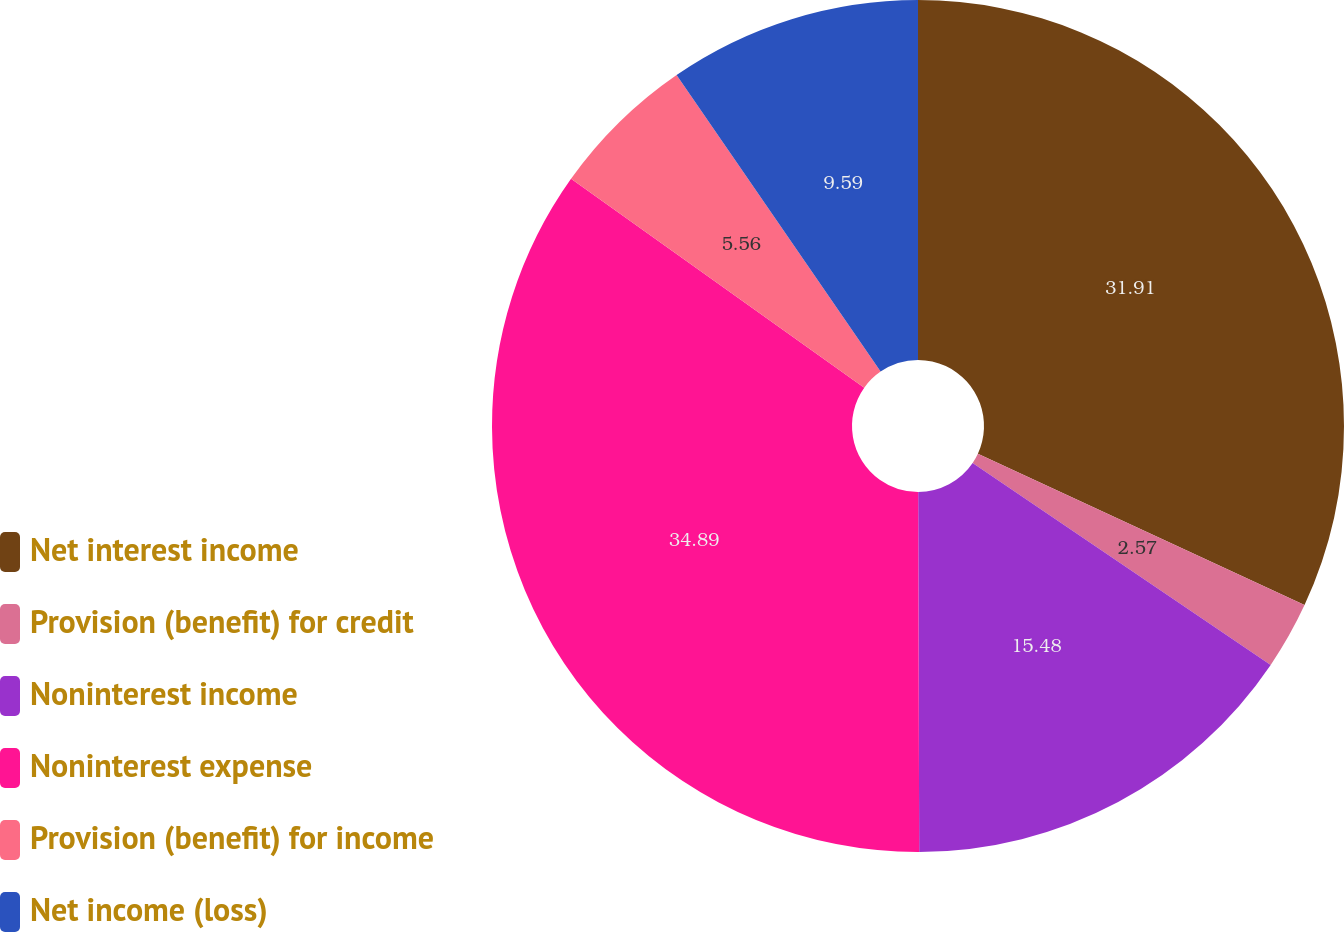Convert chart to OTSL. <chart><loc_0><loc_0><loc_500><loc_500><pie_chart><fcel>Net interest income<fcel>Provision (benefit) for credit<fcel>Noninterest income<fcel>Noninterest expense<fcel>Provision (benefit) for income<fcel>Net income (loss)<nl><fcel>31.91%<fcel>2.57%<fcel>15.48%<fcel>34.9%<fcel>5.56%<fcel>9.59%<nl></chart> 